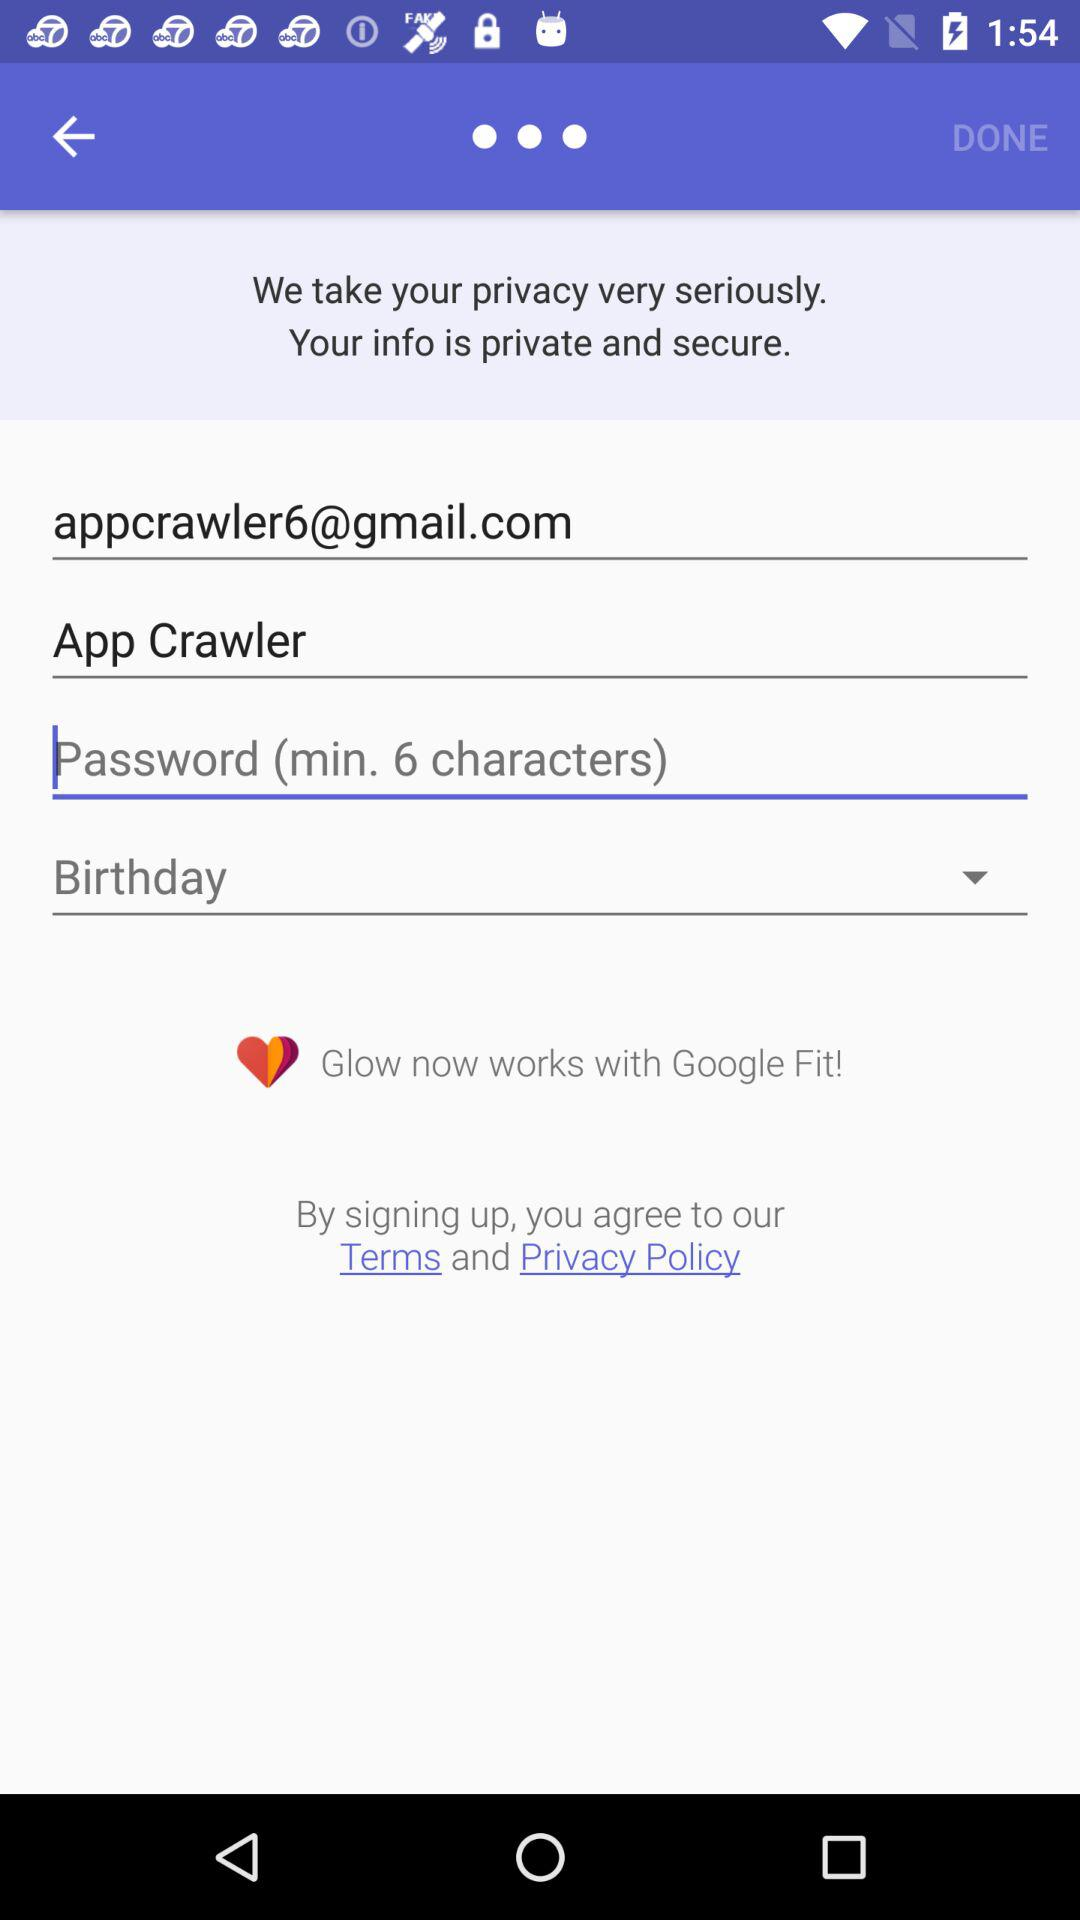What are the minimum characters required in the password? The minimum characters required in the password are 6. 